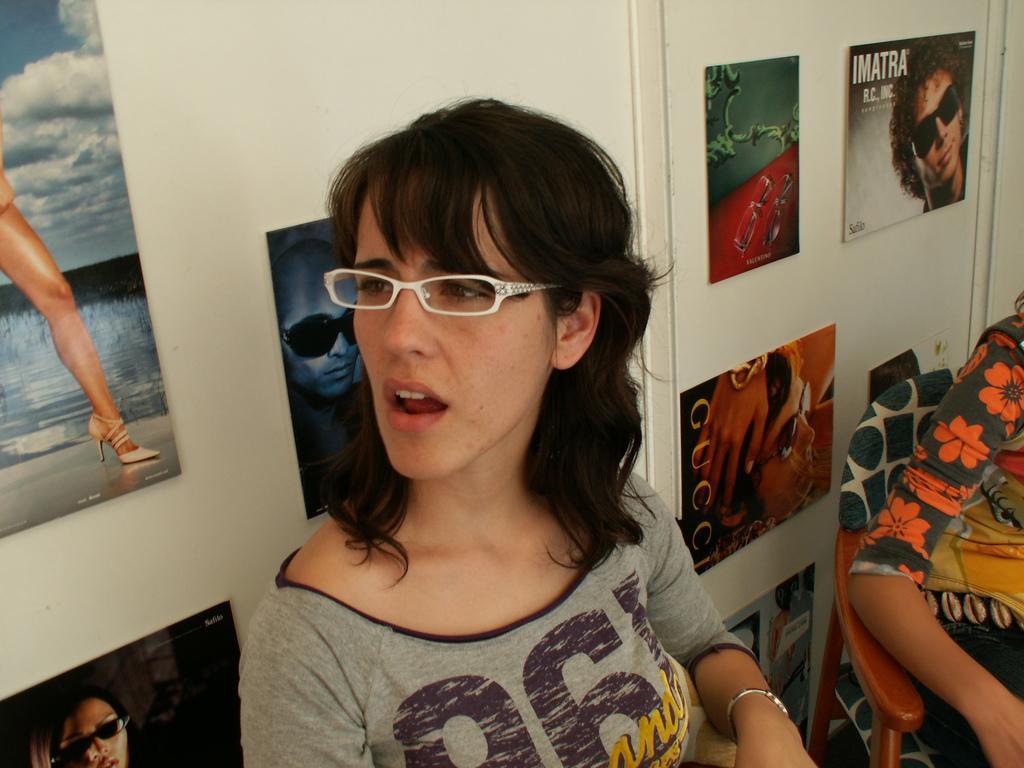In one or two sentences, can you explain what this image depicts? In this picture, we can see a lady and a person is partially covered, and we can see the wall with posters, and also we can see the chair. 